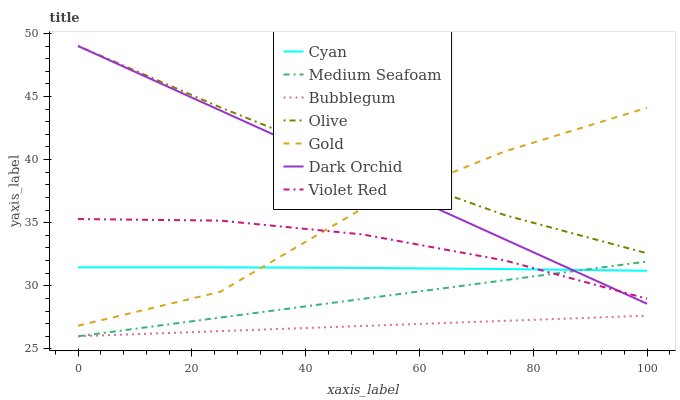Does Bubblegum have the minimum area under the curve?
Answer yes or no. Yes. Does Olive have the maximum area under the curve?
Answer yes or no. Yes. Does Gold have the minimum area under the curve?
Answer yes or no. No. Does Gold have the maximum area under the curve?
Answer yes or no. No. Is Medium Seafoam the smoothest?
Answer yes or no. Yes. Is Gold the roughest?
Answer yes or no. Yes. Is Dark Orchid the smoothest?
Answer yes or no. No. Is Dark Orchid the roughest?
Answer yes or no. No. Does Gold have the lowest value?
Answer yes or no. No. Does Olive have the highest value?
Answer yes or no. Yes. Does Gold have the highest value?
Answer yes or no. No. Is Violet Red less than Olive?
Answer yes or no. Yes. Is Olive greater than Violet Red?
Answer yes or no. Yes. Does Dark Orchid intersect Cyan?
Answer yes or no. Yes. Is Dark Orchid less than Cyan?
Answer yes or no. No. Is Dark Orchid greater than Cyan?
Answer yes or no. No. Does Violet Red intersect Olive?
Answer yes or no. No. 